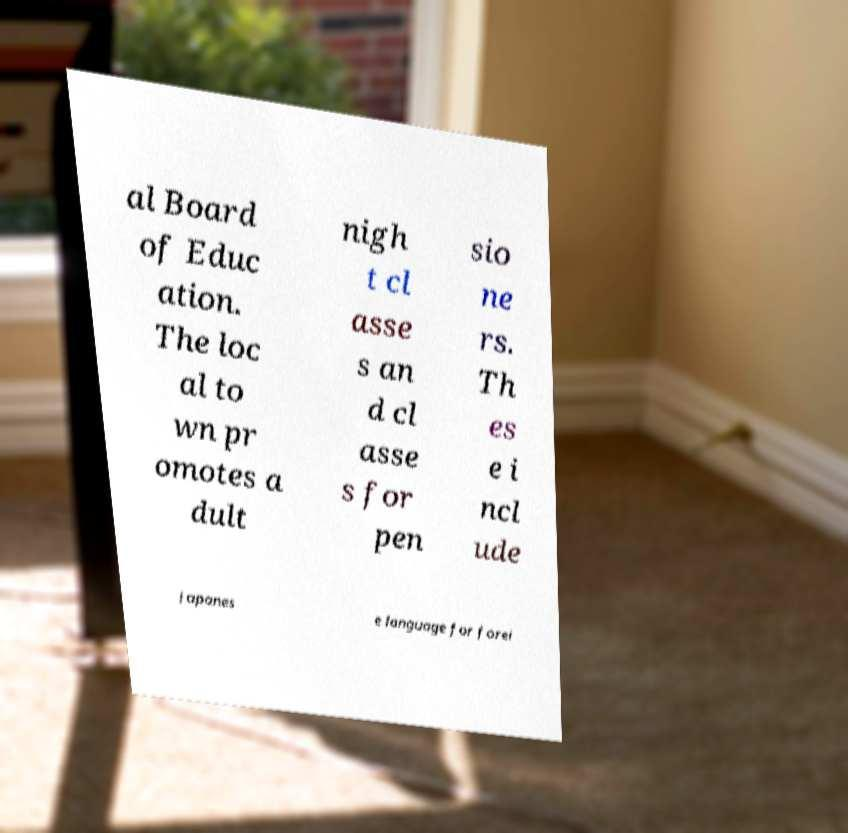I need the written content from this picture converted into text. Can you do that? al Board of Educ ation. The loc al to wn pr omotes a dult nigh t cl asse s an d cl asse s for pen sio ne rs. Th es e i ncl ude Japanes e language for forei 